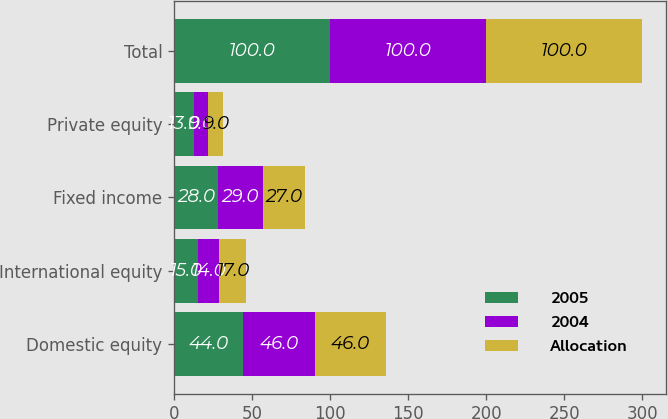Convert chart to OTSL. <chart><loc_0><loc_0><loc_500><loc_500><stacked_bar_chart><ecel><fcel>Domestic equity<fcel>International equity<fcel>Fixed income<fcel>Private equity<fcel>Total<nl><fcel>2005<fcel>44<fcel>15<fcel>28<fcel>13<fcel>100<nl><fcel>2004<fcel>46<fcel>14<fcel>29<fcel>9<fcel>100<nl><fcel>Allocation<fcel>46<fcel>17<fcel>27<fcel>9<fcel>100<nl></chart> 